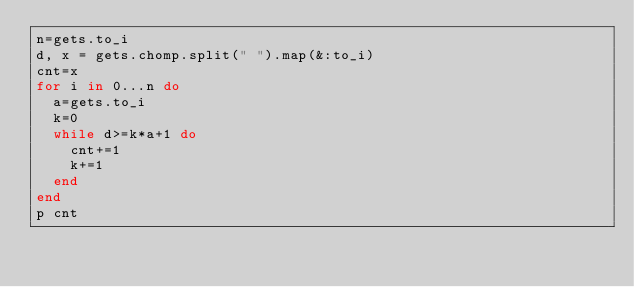Convert code to text. <code><loc_0><loc_0><loc_500><loc_500><_Ruby_>n=gets.to_i
d, x = gets.chomp.split(" ").map(&:to_i)
cnt=x
for i in 0...n do
  a=gets.to_i
  k=0
  while d>=k*a+1 do
    cnt+=1
    k+=1
  end
end
p cnt
</code> 